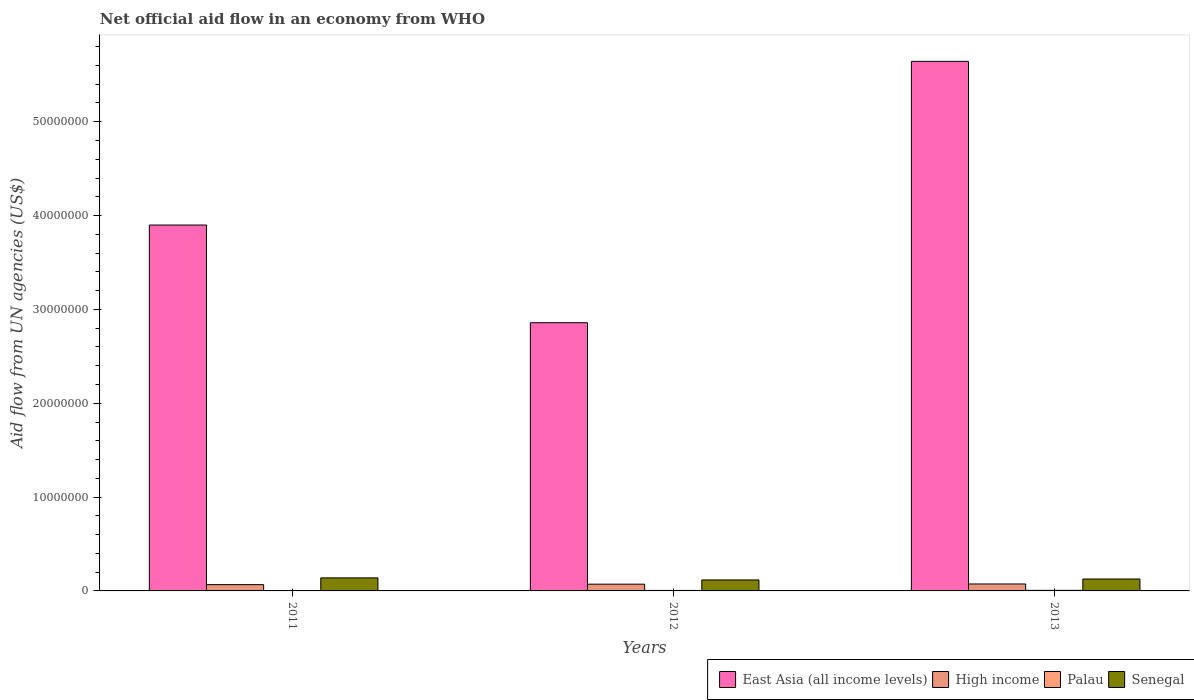How many groups of bars are there?
Offer a terse response. 3. Are the number of bars on each tick of the X-axis equal?
Your response must be concise. Yes. How many bars are there on the 2nd tick from the left?
Ensure brevity in your answer.  4. In how many cases, is the number of bars for a given year not equal to the number of legend labels?
Provide a succinct answer. 0. What is the net official aid flow in Palau in 2011?
Your response must be concise. 3.00e+04. Across all years, what is the minimum net official aid flow in East Asia (all income levels)?
Your answer should be compact. 2.86e+07. In which year was the net official aid flow in Senegal maximum?
Your answer should be very brief. 2011. In which year was the net official aid flow in Senegal minimum?
Give a very brief answer. 2012. What is the total net official aid flow in Palau in the graph?
Offer a terse response. 1.40e+05. What is the difference between the net official aid flow in Palau in 2012 and the net official aid flow in East Asia (all income levels) in 2013?
Keep it short and to the point. -5.64e+07. What is the average net official aid flow in East Asia (all income levels) per year?
Keep it short and to the point. 4.13e+07. In the year 2011, what is the difference between the net official aid flow in High income and net official aid flow in East Asia (all income levels)?
Your answer should be very brief. -3.83e+07. What is the ratio of the net official aid flow in Palau in 2012 to that in 2013?
Provide a succinct answer. 0.83. Is the net official aid flow in Senegal in 2011 less than that in 2013?
Your answer should be compact. No. Is the difference between the net official aid flow in High income in 2011 and 2013 greater than the difference between the net official aid flow in East Asia (all income levels) in 2011 and 2013?
Your answer should be compact. Yes. What is the difference between the highest and the lowest net official aid flow in Palau?
Your answer should be compact. 3.00e+04. In how many years, is the net official aid flow in High income greater than the average net official aid flow in High income taken over all years?
Make the answer very short. 2. Is it the case that in every year, the sum of the net official aid flow in Palau and net official aid flow in High income is greater than the sum of net official aid flow in Senegal and net official aid flow in East Asia (all income levels)?
Your response must be concise. No. What does the 1st bar from the left in 2012 represents?
Your answer should be very brief. East Asia (all income levels). What does the 4th bar from the right in 2012 represents?
Offer a very short reply. East Asia (all income levels). Is it the case that in every year, the sum of the net official aid flow in High income and net official aid flow in Senegal is greater than the net official aid flow in East Asia (all income levels)?
Provide a succinct answer. No. How many bars are there?
Keep it short and to the point. 12. Are all the bars in the graph horizontal?
Provide a succinct answer. No. What is the difference between two consecutive major ticks on the Y-axis?
Offer a terse response. 1.00e+07. Does the graph contain any zero values?
Offer a very short reply. No. Does the graph contain grids?
Make the answer very short. No. How are the legend labels stacked?
Your answer should be compact. Horizontal. What is the title of the graph?
Provide a short and direct response. Net official aid flow in an economy from WHO. Does "Serbia" appear as one of the legend labels in the graph?
Provide a succinct answer. No. What is the label or title of the X-axis?
Ensure brevity in your answer.  Years. What is the label or title of the Y-axis?
Ensure brevity in your answer.  Aid flow from UN agencies (US$). What is the Aid flow from UN agencies (US$) in East Asia (all income levels) in 2011?
Offer a terse response. 3.90e+07. What is the Aid flow from UN agencies (US$) in High income in 2011?
Keep it short and to the point. 6.70e+05. What is the Aid flow from UN agencies (US$) in Palau in 2011?
Provide a succinct answer. 3.00e+04. What is the Aid flow from UN agencies (US$) in Senegal in 2011?
Offer a terse response. 1.39e+06. What is the Aid flow from UN agencies (US$) of East Asia (all income levels) in 2012?
Your response must be concise. 2.86e+07. What is the Aid flow from UN agencies (US$) of High income in 2012?
Your answer should be very brief. 7.20e+05. What is the Aid flow from UN agencies (US$) of Senegal in 2012?
Provide a succinct answer. 1.17e+06. What is the Aid flow from UN agencies (US$) in East Asia (all income levels) in 2013?
Provide a short and direct response. 5.64e+07. What is the Aid flow from UN agencies (US$) in High income in 2013?
Make the answer very short. 7.40e+05. What is the Aid flow from UN agencies (US$) in Palau in 2013?
Keep it short and to the point. 6.00e+04. What is the Aid flow from UN agencies (US$) of Senegal in 2013?
Ensure brevity in your answer.  1.27e+06. Across all years, what is the maximum Aid flow from UN agencies (US$) in East Asia (all income levels)?
Your answer should be compact. 5.64e+07. Across all years, what is the maximum Aid flow from UN agencies (US$) of High income?
Ensure brevity in your answer.  7.40e+05. Across all years, what is the maximum Aid flow from UN agencies (US$) of Senegal?
Provide a succinct answer. 1.39e+06. Across all years, what is the minimum Aid flow from UN agencies (US$) of East Asia (all income levels)?
Give a very brief answer. 2.86e+07. Across all years, what is the minimum Aid flow from UN agencies (US$) in High income?
Keep it short and to the point. 6.70e+05. Across all years, what is the minimum Aid flow from UN agencies (US$) in Palau?
Your answer should be compact. 3.00e+04. Across all years, what is the minimum Aid flow from UN agencies (US$) in Senegal?
Keep it short and to the point. 1.17e+06. What is the total Aid flow from UN agencies (US$) in East Asia (all income levels) in the graph?
Provide a succinct answer. 1.24e+08. What is the total Aid flow from UN agencies (US$) of High income in the graph?
Offer a terse response. 2.13e+06. What is the total Aid flow from UN agencies (US$) of Palau in the graph?
Keep it short and to the point. 1.40e+05. What is the total Aid flow from UN agencies (US$) of Senegal in the graph?
Provide a succinct answer. 3.83e+06. What is the difference between the Aid flow from UN agencies (US$) of East Asia (all income levels) in 2011 and that in 2012?
Give a very brief answer. 1.04e+07. What is the difference between the Aid flow from UN agencies (US$) in Palau in 2011 and that in 2012?
Give a very brief answer. -2.00e+04. What is the difference between the Aid flow from UN agencies (US$) of East Asia (all income levels) in 2011 and that in 2013?
Make the answer very short. -1.74e+07. What is the difference between the Aid flow from UN agencies (US$) in Palau in 2011 and that in 2013?
Keep it short and to the point. -3.00e+04. What is the difference between the Aid flow from UN agencies (US$) in East Asia (all income levels) in 2012 and that in 2013?
Provide a short and direct response. -2.78e+07. What is the difference between the Aid flow from UN agencies (US$) of High income in 2012 and that in 2013?
Ensure brevity in your answer.  -2.00e+04. What is the difference between the Aid flow from UN agencies (US$) of Senegal in 2012 and that in 2013?
Offer a terse response. -1.00e+05. What is the difference between the Aid flow from UN agencies (US$) of East Asia (all income levels) in 2011 and the Aid flow from UN agencies (US$) of High income in 2012?
Offer a very short reply. 3.83e+07. What is the difference between the Aid flow from UN agencies (US$) in East Asia (all income levels) in 2011 and the Aid flow from UN agencies (US$) in Palau in 2012?
Your answer should be very brief. 3.89e+07. What is the difference between the Aid flow from UN agencies (US$) of East Asia (all income levels) in 2011 and the Aid flow from UN agencies (US$) of Senegal in 2012?
Provide a short and direct response. 3.78e+07. What is the difference between the Aid flow from UN agencies (US$) in High income in 2011 and the Aid flow from UN agencies (US$) in Palau in 2012?
Your answer should be very brief. 6.20e+05. What is the difference between the Aid flow from UN agencies (US$) of High income in 2011 and the Aid flow from UN agencies (US$) of Senegal in 2012?
Keep it short and to the point. -5.00e+05. What is the difference between the Aid flow from UN agencies (US$) in Palau in 2011 and the Aid flow from UN agencies (US$) in Senegal in 2012?
Make the answer very short. -1.14e+06. What is the difference between the Aid flow from UN agencies (US$) in East Asia (all income levels) in 2011 and the Aid flow from UN agencies (US$) in High income in 2013?
Your answer should be very brief. 3.82e+07. What is the difference between the Aid flow from UN agencies (US$) of East Asia (all income levels) in 2011 and the Aid flow from UN agencies (US$) of Palau in 2013?
Offer a very short reply. 3.89e+07. What is the difference between the Aid flow from UN agencies (US$) of East Asia (all income levels) in 2011 and the Aid flow from UN agencies (US$) of Senegal in 2013?
Provide a short and direct response. 3.77e+07. What is the difference between the Aid flow from UN agencies (US$) in High income in 2011 and the Aid flow from UN agencies (US$) in Palau in 2013?
Offer a very short reply. 6.10e+05. What is the difference between the Aid flow from UN agencies (US$) in High income in 2011 and the Aid flow from UN agencies (US$) in Senegal in 2013?
Your response must be concise. -6.00e+05. What is the difference between the Aid flow from UN agencies (US$) in Palau in 2011 and the Aid flow from UN agencies (US$) in Senegal in 2013?
Offer a very short reply. -1.24e+06. What is the difference between the Aid flow from UN agencies (US$) of East Asia (all income levels) in 2012 and the Aid flow from UN agencies (US$) of High income in 2013?
Provide a succinct answer. 2.78e+07. What is the difference between the Aid flow from UN agencies (US$) in East Asia (all income levels) in 2012 and the Aid flow from UN agencies (US$) in Palau in 2013?
Provide a short and direct response. 2.85e+07. What is the difference between the Aid flow from UN agencies (US$) in East Asia (all income levels) in 2012 and the Aid flow from UN agencies (US$) in Senegal in 2013?
Ensure brevity in your answer.  2.73e+07. What is the difference between the Aid flow from UN agencies (US$) in High income in 2012 and the Aid flow from UN agencies (US$) in Palau in 2013?
Your response must be concise. 6.60e+05. What is the difference between the Aid flow from UN agencies (US$) in High income in 2012 and the Aid flow from UN agencies (US$) in Senegal in 2013?
Give a very brief answer. -5.50e+05. What is the difference between the Aid flow from UN agencies (US$) in Palau in 2012 and the Aid flow from UN agencies (US$) in Senegal in 2013?
Make the answer very short. -1.22e+06. What is the average Aid flow from UN agencies (US$) in East Asia (all income levels) per year?
Provide a short and direct response. 4.13e+07. What is the average Aid flow from UN agencies (US$) in High income per year?
Ensure brevity in your answer.  7.10e+05. What is the average Aid flow from UN agencies (US$) in Palau per year?
Offer a terse response. 4.67e+04. What is the average Aid flow from UN agencies (US$) in Senegal per year?
Your answer should be compact. 1.28e+06. In the year 2011, what is the difference between the Aid flow from UN agencies (US$) in East Asia (all income levels) and Aid flow from UN agencies (US$) in High income?
Your answer should be compact. 3.83e+07. In the year 2011, what is the difference between the Aid flow from UN agencies (US$) of East Asia (all income levels) and Aid flow from UN agencies (US$) of Palau?
Your answer should be very brief. 3.90e+07. In the year 2011, what is the difference between the Aid flow from UN agencies (US$) in East Asia (all income levels) and Aid flow from UN agencies (US$) in Senegal?
Your answer should be very brief. 3.76e+07. In the year 2011, what is the difference between the Aid flow from UN agencies (US$) of High income and Aid flow from UN agencies (US$) of Palau?
Your response must be concise. 6.40e+05. In the year 2011, what is the difference between the Aid flow from UN agencies (US$) in High income and Aid flow from UN agencies (US$) in Senegal?
Provide a succinct answer. -7.20e+05. In the year 2011, what is the difference between the Aid flow from UN agencies (US$) in Palau and Aid flow from UN agencies (US$) in Senegal?
Ensure brevity in your answer.  -1.36e+06. In the year 2012, what is the difference between the Aid flow from UN agencies (US$) of East Asia (all income levels) and Aid flow from UN agencies (US$) of High income?
Your answer should be very brief. 2.79e+07. In the year 2012, what is the difference between the Aid flow from UN agencies (US$) of East Asia (all income levels) and Aid flow from UN agencies (US$) of Palau?
Ensure brevity in your answer.  2.85e+07. In the year 2012, what is the difference between the Aid flow from UN agencies (US$) in East Asia (all income levels) and Aid flow from UN agencies (US$) in Senegal?
Provide a short and direct response. 2.74e+07. In the year 2012, what is the difference between the Aid flow from UN agencies (US$) in High income and Aid flow from UN agencies (US$) in Palau?
Keep it short and to the point. 6.70e+05. In the year 2012, what is the difference between the Aid flow from UN agencies (US$) in High income and Aid flow from UN agencies (US$) in Senegal?
Make the answer very short. -4.50e+05. In the year 2012, what is the difference between the Aid flow from UN agencies (US$) in Palau and Aid flow from UN agencies (US$) in Senegal?
Your response must be concise. -1.12e+06. In the year 2013, what is the difference between the Aid flow from UN agencies (US$) in East Asia (all income levels) and Aid flow from UN agencies (US$) in High income?
Your response must be concise. 5.57e+07. In the year 2013, what is the difference between the Aid flow from UN agencies (US$) in East Asia (all income levels) and Aid flow from UN agencies (US$) in Palau?
Your response must be concise. 5.64e+07. In the year 2013, what is the difference between the Aid flow from UN agencies (US$) in East Asia (all income levels) and Aid flow from UN agencies (US$) in Senegal?
Offer a terse response. 5.52e+07. In the year 2013, what is the difference between the Aid flow from UN agencies (US$) of High income and Aid flow from UN agencies (US$) of Palau?
Offer a terse response. 6.80e+05. In the year 2013, what is the difference between the Aid flow from UN agencies (US$) in High income and Aid flow from UN agencies (US$) in Senegal?
Offer a terse response. -5.30e+05. In the year 2013, what is the difference between the Aid flow from UN agencies (US$) in Palau and Aid flow from UN agencies (US$) in Senegal?
Make the answer very short. -1.21e+06. What is the ratio of the Aid flow from UN agencies (US$) in East Asia (all income levels) in 2011 to that in 2012?
Provide a short and direct response. 1.36. What is the ratio of the Aid flow from UN agencies (US$) of High income in 2011 to that in 2012?
Make the answer very short. 0.93. What is the ratio of the Aid flow from UN agencies (US$) in Senegal in 2011 to that in 2012?
Give a very brief answer. 1.19. What is the ratio of the Aid flow from UN agencies (US$) in East Asia (all income levels) in 2011 to that in 2013?
Offer a very short reply. 0.69. What is the ratio of the Aid flow from UN agencies (US$) of High income in 2011 to that in 2013?
Ensure brevity in your answer.  0.91. What is the ratio of the Aid flow from UN agencies (US$) in Palau in 2011 to that in 2013?
Ensure brevity in your answer.  0.5. What is the ratio of the Aid flow from UN agencies (US$) of Senegal in 2011 to that in 2013?
Your response must be concise. 1.09. What is the ratio of the Aid flow from UN agencies (US$) of East Asia (all income levels) in 2012 to that in 2013?
Provide a succinct answer. 0.51. What is the ratio of the Aid flow from UN agencies (US$) in High income in 2012 to that in 2013?
Your answer should be very brief. 0.97. What is the ratio of the Aid flow from UN agencies (US$) in Palau in 2012 to that in 2013?
Make the answer very short. 0.83. What is the ratio of the Aid flow from UN agencies (US$) of Senegal in 2012 to that in 2013?
Make the answer very short. 0.92. What is the difference between the highest and the second highest Aid flow from UN agencies (US$) in East Asia (all income levels)?
Your answer should be compact. 1.74e+07. What is the difference between the highest and the second highest Aid flow from UN agencies (US$) in Palau?
Your answer should be compact. 10000. What is the difference between the highest and the lowest Aid flow from UN agencies (US$) in East Asia (all income levels)?
Offer a terse response. 2.78e+07. What is the difference between the highest and the lowest Aid flow from UN agencies (US$) of Palau?
Give a very brief answer. 3.00e+04. 